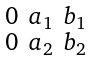Convert formula to latex. <formula><loc_0><loc_0><loc_500><loc_500>\begin{smallmatrix} 0 & a _ { 1 } & b _ { 1 } \\ 0 & a _ { 2 } & b _ { 2 } \end{smallmatrix}</formula> 